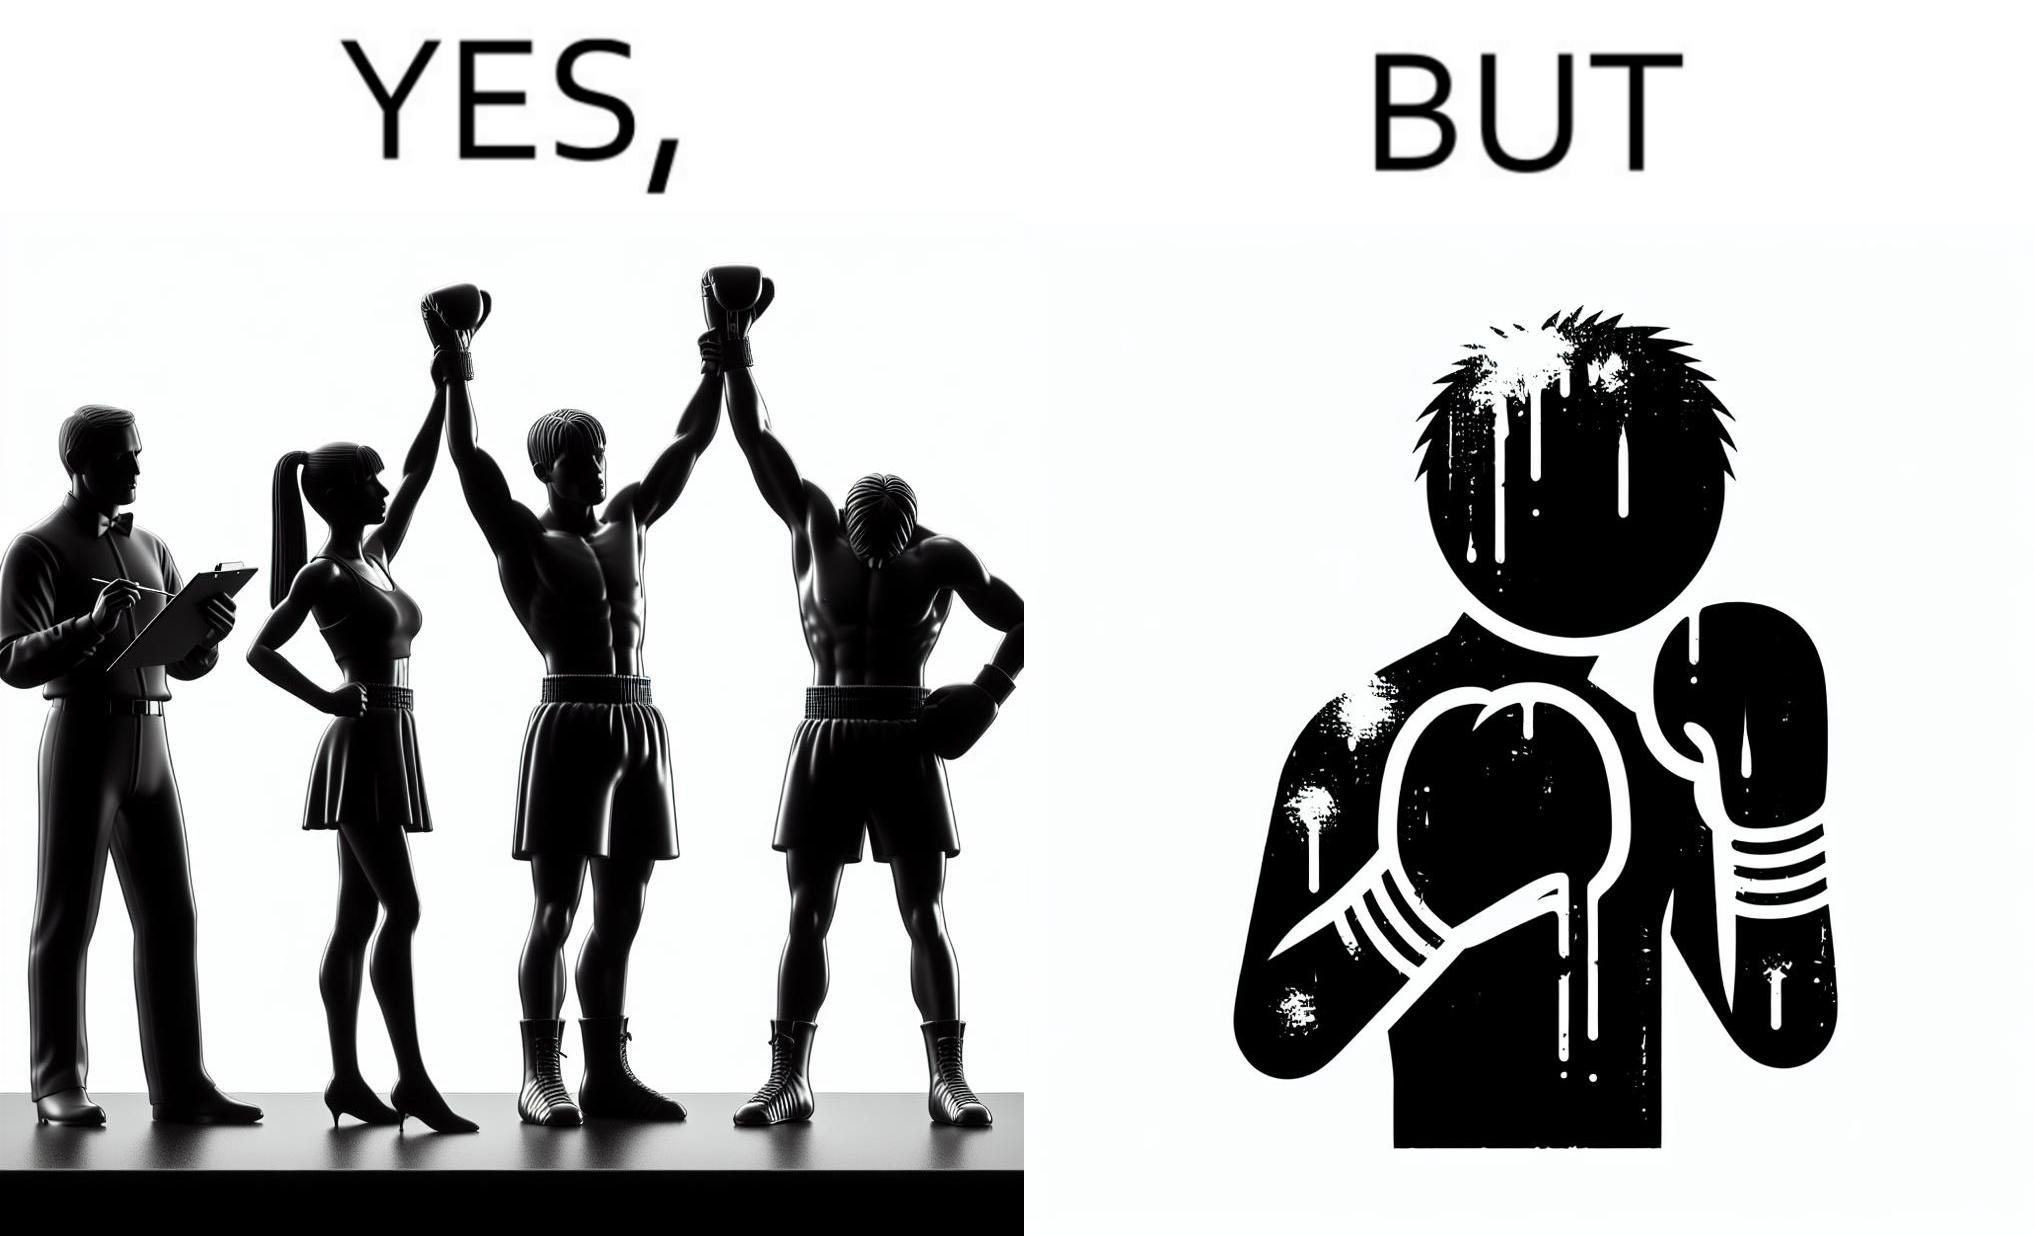What is shown in the left half versus the right half of this image? In the left part of the image: a referee announcing the winner of a boxing match. In the right part of the image: a bruised boxer. 